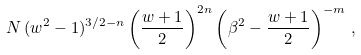Convert formula to latex. <formula><loc_0><loc_0><loc_500><loc_500>N \, ( w ^ { 2 } - 1 ) ^ { 3 / 2 - n } \left ( \frac { w + 1 } { 2 } \right ) ^ { 2 n } \left ( \beta ^ { 2 } - \frac { w + 1 } { 2 } \right ) ^ { - m } \, ,</formula> 